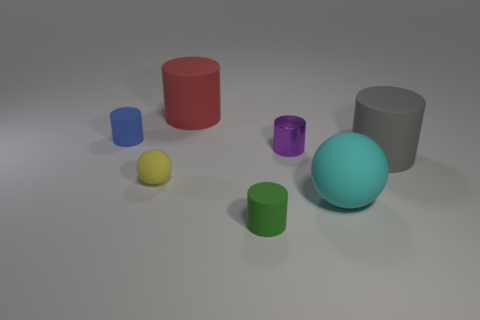There is a matte object that is both right of the red rubber cylinder and to the left of the big cyan object; what is its shape?
Provide a short and direct response. Cylinder. How many things are either cylinders that are behind the big cyan rubber sphere or rubber objects that are in front of the gray thing?
Offer a very short reply. 7. Are there the same number of small cylinders that are left of the yellow sphere and purple metal cylinders in front of the small blue rubber thing?
Give a very brief answer. Yes. There is a large rubber object behind the tiny matte cylinder that is left of the tiny yellow object; what is its shape?
Your answer should be very brief. Cylinder. Are there any other objects of the same shape as the tiny yellow object?
Make the answer very short. Yes. How many tiny green rubber things are there?
Your answer should be very brief. 1. Is the material of the cylinder in front of the large cyan ball the same as the cyan thing?
Your response must be concise. Yes. Are there any things that have the same size as the purple cylinder?
Provide a short and direct response. Yes. Does the large red matte object have the same shape as the tiny matte thing that is behind the gray matte cylinder?
Make the answer very short. Yes. Is there a tiny yellow rubber object on the right side of the small rubber cylinder in front of the matte thing left of the small yellow sphere?
Provide a succinct answer. No. 